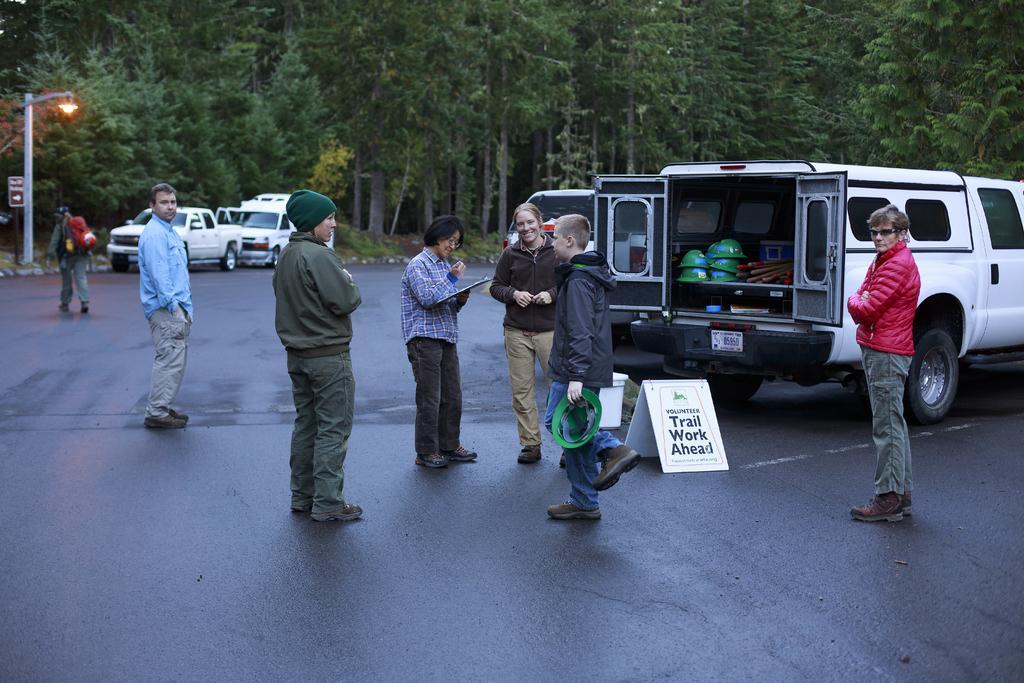Could you give a brief overview of what you see in this image? In this image I can see a group of people are standing on the road, boards and fleets of vehicles. In the background I can see a light pole and trees. This image is taken may be during a day on the road. 